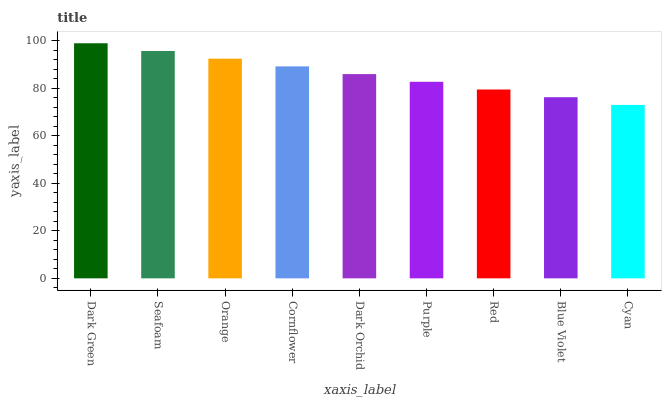Is Cyan the minimum?
Answer yes or no. Yes. Is Dark Green the maximum?
Answer yes or no. Yes. Is Seafoam the minimum?
Answer yes or no. No. Is Seafoam the maximum?
Answer yes or no. No. Is Dark Green greater than Seafoam?
Answer yes or no. Yes. Is Seafoam less than Dark Green?
Answer yes or no. Yes. Is Seafoam greater than Dark Green?
Answer yes or no. No. Is Dark Green less than Seafoam?
Answer yes or no. No. Is Dark Orchid the high median?
Answer yes or no. Yes. Is Dark Orchid the low median?
Answer yes or no. Yes. Is Cyan the high median?
Answer yes or no. No. Is Cyan the low median?
Answer yes or no. No. 